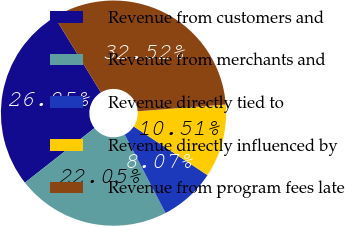Convert chart to OTSL. <chart><loc_0><loc_0><loc_500><loc_500><pie_chart><fcel>Revenue from customers and<fcel>Revenue from merchants and<fcel>Revenue directly tied to<fcel>Revenue directly influenced by<fcel>Revenue from program fees late<nl><fcel>26.85%<fcel>22.05%<fcel>8.07%<fcel>10.51%<fcel>32.52%<nl></chart> 